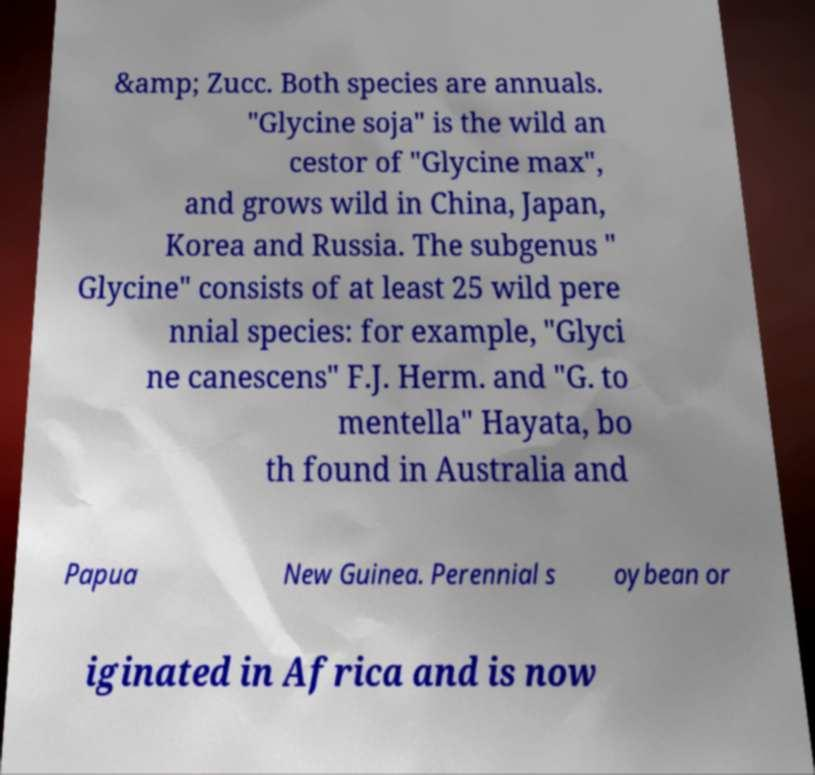Could you assist in decoding the text presented in this image and type it out clearly? &amp; Zucc. Both species are annuals. "Glycine soja" is the wild an cestor of "Glycine max", and grows wild in China, Japan, Korea and Russia. The subgenus " Glycine" consists of at least 25 wild pere nnial species: for example, "Glyci ne canescens" F.J. Herm. and "G. to mentella" Hayata, bo th found in Australia and Papua New Guinea. Perennial s oybean or iginated in Africa and is now 